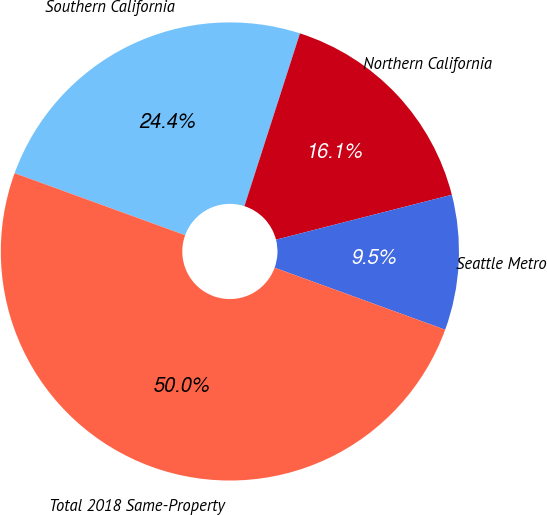<chart> <loc_0><loc_0><loc_500><loc_500><pie_chart><fcel>Southern California<fcel>Northern California<fcel>Seattle Metro<fcel>Total 2018 Same-Property<nl><fcel>24.4%<fcel>16.07%<fcel>9.53%<fcel>50.0%<nl></chart> 